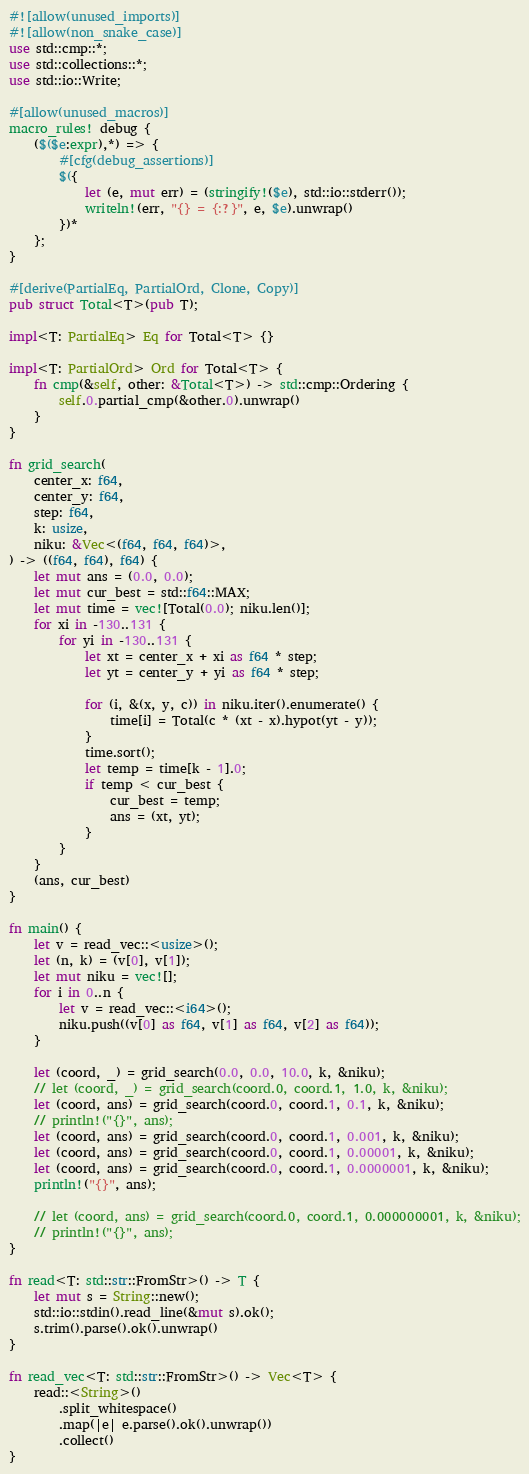<code> <loc_0><loc_0><loc_500><loc_500><_Rust_>#![allow(unused_imports)]
#![allow(non_snake_case)]
use std::cmp::*;
use std::collections::*;
use std::io::Write;

#[allow(unused_macros)]
macro_rules! debug {
    ($($e:expr),*) => {
        #[cfg(debug_assertions)]
        $({
            let (e, mut err) = (stringify!($e), std::io::stderr());
            writeln!(err, "{} = {:?}", e, $e).unwrap()
        })*
    };
}

#[derive(PartialEq, PartialOrd, Clone, Copy)]
pub struct Total<T>(pub T);

impl<T: PartialEq> Eq for Total<T> {}

impl<T: PartialOrd> Ord for Total<T> {
    fn cmp(&self, other: &Total<T>) -> std::cmp::Ordering {
        self.0.partial_cmp(&other.0).unwrap()
    }
}

fn grid_search(
    center_x: f64,
    center_y: f64,
    step: f64,
    k: usize,
    niku: &Vec<(f64, f64, f64)>,
) -> ((f64, f64), f64) {
    let mut ans = (0.0, 0.0);
    let mut cur_best = std::f64::MAX;
    let mut time = vec![Total(0.0); niku.len()];
    for xi in -130..131 {
        for yi in -130..131 {
            let xt = center_x + xi as f64 * step;
            let yt = center_y + yi as f64 * step;

            for (i, &(x, y, c)) in niku.iter().enumerate() {
                time[i] = Total(c * (xt - x).hypot(yt - y));
            }
            time.sort();
            let temp = time[k - 1].0;
            if temp < cur_best {
                cur_best = temp;
                ans = (xt, yt);
            }
        }
    }
    (ans, cur_best)
}

fn main() {
    let v = read_vec::<usize>();
    let (n, k) = (v[0], v[1]);
    let mut niku = vec![];
    for i in 0..n {
        let v = read_vec::<i64>();
        niku.push((v[0] as f64, v[1] as f64, v[2] as f64));
    }

    let (coord, _) = grid_search(0.0, 0.0, 10.0, k, &niku);
    // let (coord, _) = grid_search(coord.0, coord.1, 1.0, k, &niku);
    let (coord, ans) = grid_search(coord.0, coord.1, 0.1, k, &niku);
    // println!("{}", ans);
    let (coord, ans) = grid_search(coord.0, coord.1, 0.001, k, &niku);
    let (coord, ans) = grid_search(coord.0, coord.1, 0.00001, k, &niku);
    let (coord, ans) = grid_search(coord.0, coord.1, 0.0000001, k, &niku);
    println!("{}", ans);

    // let (coord, ans) = grid_search(coord.0, coord.1, 0.000000001, k, &niku);
    // println!("{}", ans);
}

fn read<T: std::str::FromStr>() -> T {
    let mut s = String::new();
    std::io::stdin().read_line(&mut s).ok();
    s.trim().parse().ok().unwrap()
}

fn read_vec<T: std::str::FromStr>() -> Vec<T> {
    read::<String>()
        .split_whitespace()
        .map(|e| e.parse().ok().unwrap())
        .collect()
}
</code> 